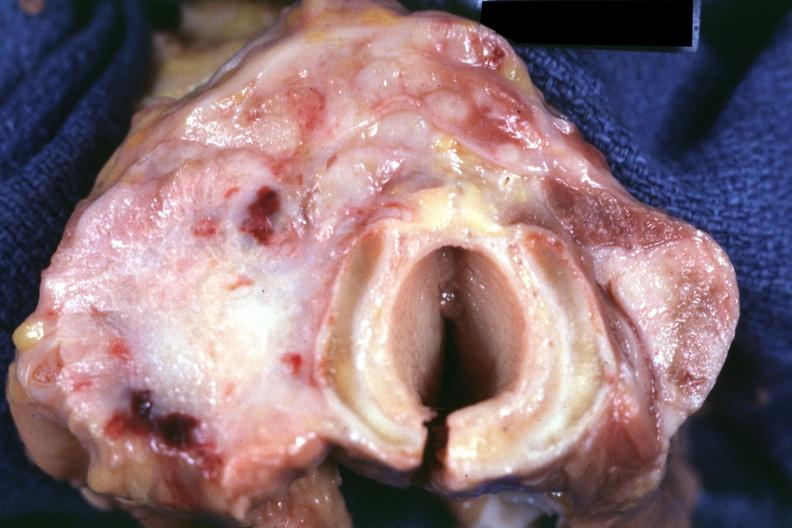what had metastases to lungs , pleura , liver and regional nodes?
Answer the question using a single word or phrase. Carcinoma 